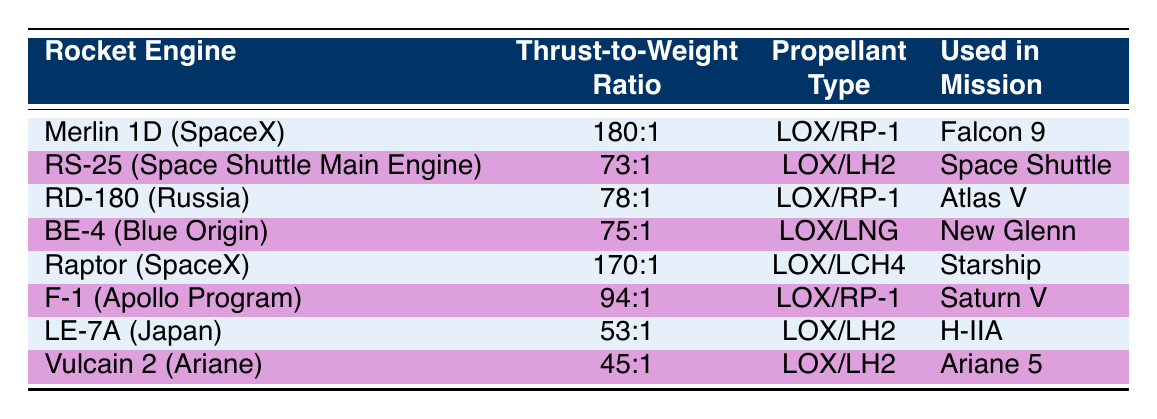What is the thrust-to-weight ratio of the Merlin 1D rocket engine? The table directly displays the thrust-to-weight ratio for the Merlin 1D as "180:1" in the second column.
Answer: 180:1 Which rocket engine uses LOX/LH2 as its propellant? Looking through the table, the RS-25 rocket engine is listed with LOX/LH2 in the third column.
Answer: RS-25 (Space Shuttle Main Engine) What is the difference in thrust-to-weight ratio between the Raptor and F-1 rocket engines? The Raptor has a thrust-to-weight ratio of 170:1, and the F-1 has 94:1. The difference can be calculated as 170 - 94 = 76.
Answer: 76 Which rocket engines have a thrust-to-weight ratio greater than 75:1? The engines with a thrust-to-weight ratio greater than 75:1 are Merlin 1D (180:1), Raptor (170:1), and F-1 (94:1). This includes those ratios only.
Answer: Merlin 1D, Raptor, F-1 Is the Vulcain 2 engine used in a mission? The table lists the Vulcain 2 under "Used in Mission," which shows it is used in the Ariane 5 mission. Hence, the answer is yes.
Answer: Yes Which rocket engine has the lowest thrust-to-weight ratio? By examining the thrust-to-weight ratios in the table, Vulcain 2 has the lowest at 45:1 when comparing all the listed ratios.
Answer: Vulcain 2 What is the average thrust-to-weight ratio of all the listed engines? The thrust-to-weight ratios are 180:1, 73:1, 78:1, 75:1, 170:1, 94:1, 53:1, and 45:1. First, sum them: 180 + 73 + 78 + 75 + 170 + 94 + 53 + 45 = 868. Then, divide by the number of engines (8) to get the average: 868/8 = 108.5.
Answer: 108.5 Is the BE-4 rocket engine associated with the New Glenn mission? Yes, the table indicates that the BE-4 rocket engine is indeed used in the New Glenn mission. The data confirms this relationship.
Answer: Yes 